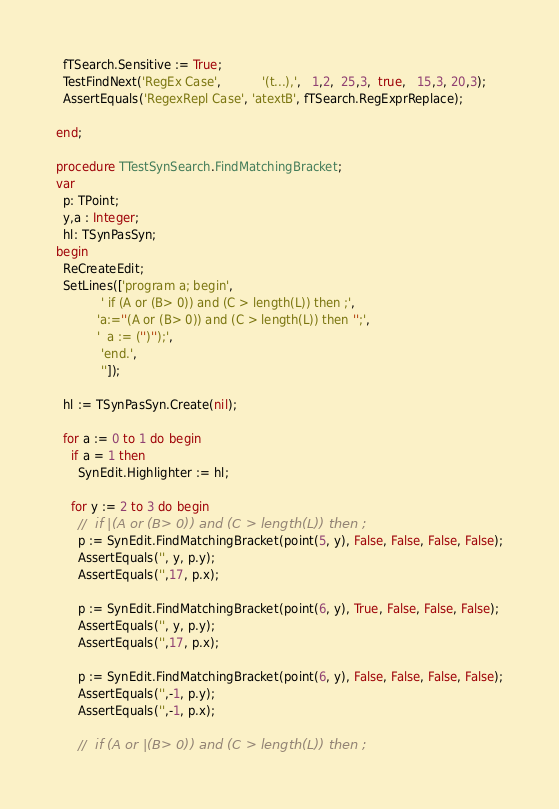Convert code to text. <code><loc_0><loc_0><loc_500><loc_500><_Pascal_>
  fTSearch.Sensitive := True;
  TestFindNext('RegEx Case',           '(t...),',   1,2,  25,3,  true,   15,3, 20,3);
  AssertEquals('RegexRepl Case', 'atextB', fTSearch.RegExprReplace);

end;

procedure TTestSynSearch.FindMatchingBracket;
var
  p: TPoint;
  y,a : Integer;
  hl: TSynPasSyn;
begin
  ReCreateEdit;
  SetLines(['program a; begin',
            ' if (A or (B> 0)) and (C > length(L)) then ;',
           'a:=''(A or (B> 0)) and (C > length(L)) then '';',
           '  a := ('')'');',
            'end.',
            '']);

  hl := TSynPasSyn.Create(nil);

  for a := 0 to 1 do begin
    if a = 1 then
      SynEdit.Highlighter := hl;

    for y := 2 to 3 do begin
      //  if |(A or (B> 0)) and (C > length(L)) then ;
      p := SynEdit.FindMatchingBracket(point(5, y), False, False, False, False);
      AssertEquals('', y, p.y);
      AssertEquals('',17, p.x);

      p := SynEdit.FindMatchingBracket(point(6, y), True, False, False, False);
      AssertEquals('', y, p.y);
      AssertEquals('',17, p.x);

      p := SynEdit.FindMatchingBracket(point(6, y), False, False, False, False);
      AssertEquals('',-1, p.y);
      AssertEquals('',-1, p.x);

      //  if (A or |(B> 0)) and (C > length(L)) then ;</code> 